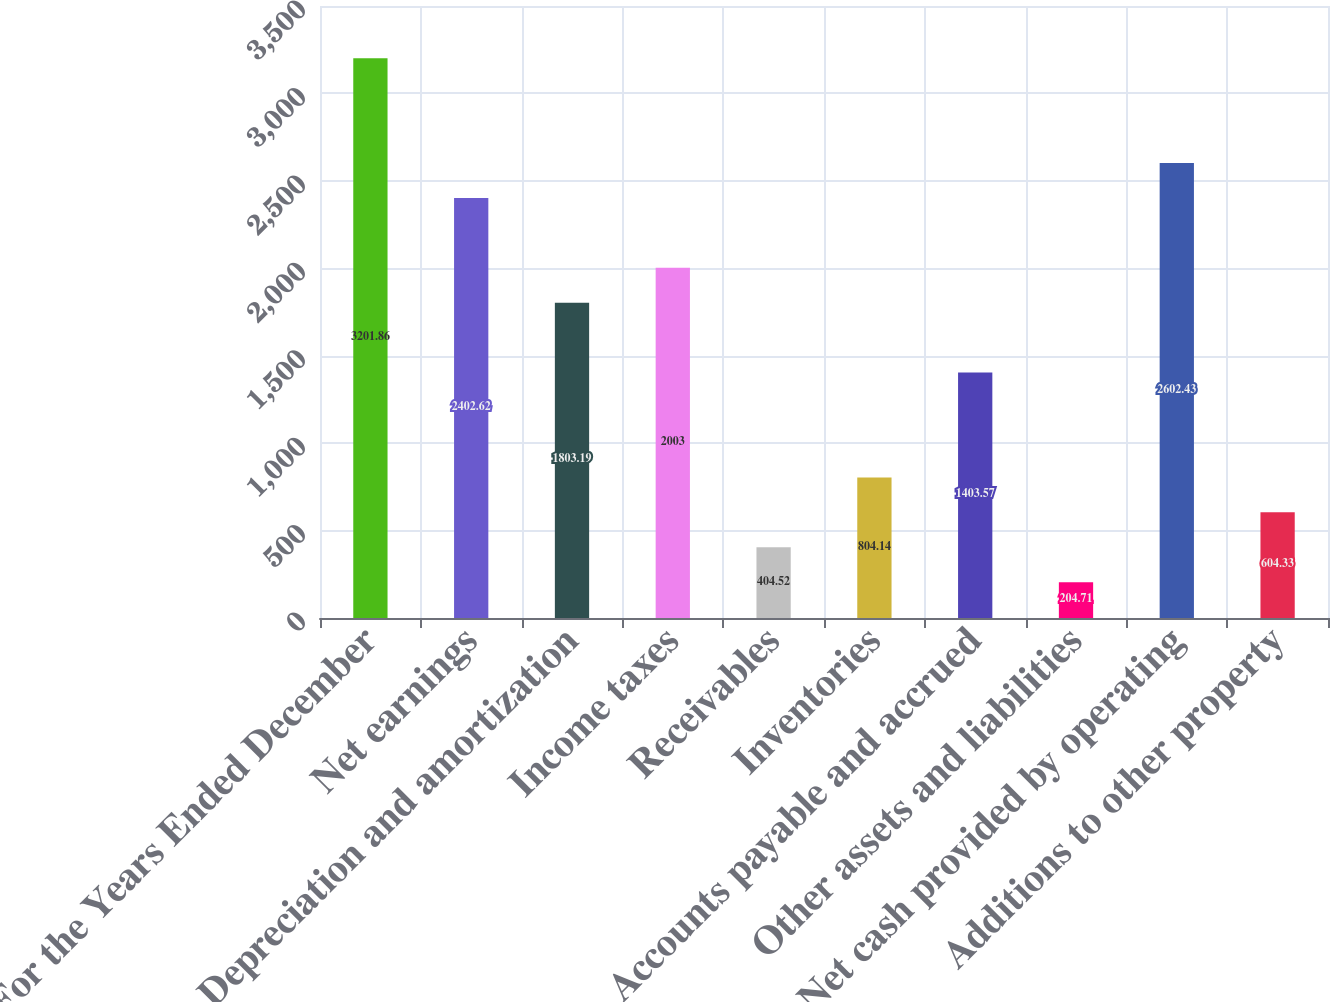<chart> <loc_0><loc_0><loc_500><loc_500><bar_chart><fcel>For the Years Ended December<fcel>Net earnings<fcel>Depreciation and amortization<fcel>Income taxes<fcel>Receivables<fcel>Inventories<fcel>Accounts payable and accrued<fcel>Other assets and liabilities<fcel>Net cash provided by operating<fcel>Additions to other property<nl><fcel>3201.86<fcel>2402.62<fcel>1803.19<fcel>2003<fcel>404.52<fcel>804.14<fcel>1403.57<fcel>204.71<fcel>2602.43<fcel>604.33<nl></chart> 